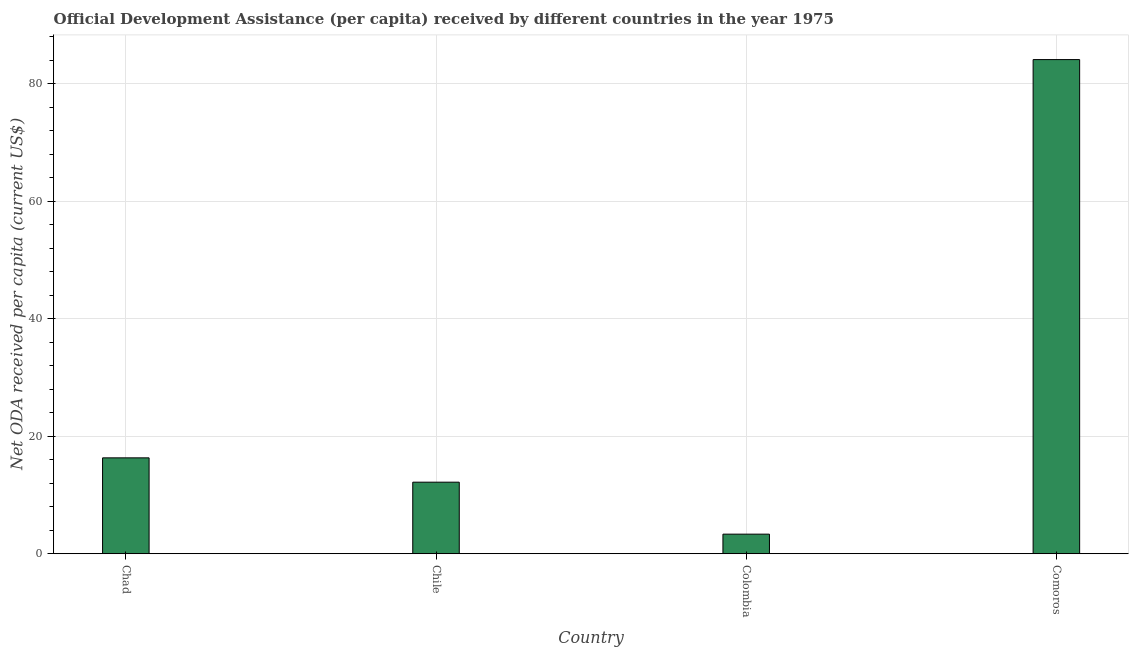Does the graph contain any zero values?
Your answer should be very brief. No. What is the title of the graph?
Make the answer very short. Official Development Assistance (per capita) received by different countries in the year 1975. What is the label or title of the Y-axis?
Your answer should be very brief. Net ODA received per capita (current US$). What is the net oda received per capita in Chad?
Make the answer very short. 16.32. Across all countries, what is the maximum net oda received per capita?
Give a very brief answer. 84.12. Across all countries, what is the minimum net oda received per capita?
Keep it short and to the point. 3.33. In which country was the net oda received per capita maximum?
Your response must be concise. Comoros. What is the sum of the net oda received per capita?
Keep it short and to the point. 115.95. What is the difference between the net oda received per capita in Chad and Colombia?
Give a very brief answer. 12.99. What is the average net oda received per capita per country?
Ensure brevity in your answer.  28.99. What is the median net oda received per capita?
Ensure brevity in your answer.  14.25. In how many countries, is the net oda received per capita greater than 40 US$?
Keep it short and to the point. 1. What is the ratio of the net oda received per capita in Chile to that in Comoros?
Give a very brief answer. 0.14. Is the net oda received per capita in Chad less than that in Chile?
Make the answer very short. No. What is the difference between the highest and the second highest net oda received per capita?
Ensure brevity in your answer.  67.8. What is the difference between the highest and the lowest net oda received per capita?
Your response must be concise. 80.78. How many bars are there?
Your answer should be very brief. 4. Are all the bars in the graph horizontal?
Provide a succinct answer. No. How many countries are there in the graph?
Ensure brevity in your answer.  4. What is the difference between two consecutive major ticks on the Y-axis?
Your answer should be compact. 20. What is the Net ODA received per capita (current US$) in Chad?
Offer a very short reply. 16.32. What is the Net ODA received per capita (current US$) in Chile?
Your response must be concise. 12.18. What is the Net ODA received per capita (current US$) in Colombia?
Offer a very short reply. 3.33. What is the Net ODA received per capita (current US$) in Comoros?
Offer a terse response. 84.12. What is the difference between the Net ODA received per capita (current US$) in Chad and Chile?
Your answer should be very brief. 4.14. What is the difference between the Net ODA received per capita (current US$) in Chad and Colombia?
Your answer should be very brief. 12.99. What is the difference between the Net ODA received per capita (current US$) in Chad and Comoros?
Give a very brief answer. -67.8. What is the difference between the Net ODA received per capita (current US$) in Chile and Colombia?
Provide a short and direct response. 8.85. What is the difference between the Net ODA received per capita (current US$) in Chile and Comoros?
Make the answer very short. -71.94. What is the difference between the Net ODA received per capita (current US$) in Colombia and Comoros?
Your answer should be very brief. -80.78. What is the ratio of the Net ODA received per capita (current US$) in Chad to that in Chile?
Offer a very short reply. 1.34. What is the ratio of the Net ODA received per capita (current US$) in Chad to that in Colombia?
Make the answer very short. 4.9. What is the ratio of the Net ODA received per capita (current US$) in Chad to that in Comoros?
Offer a very short reply. 0.19. What is the ratio of the Net ODA received per capita (current US$) in Chile to that in Colombia?
Offer a very short reply. 3.65. What is the ratio of the Net ODA received per capita (current US$) in Chile to that in Comoros?
Your response must be concise. 0.14. What is the ratio of the Net ODA received per capita (current US$) in Colombia to that in Comoros?
Offer a terse response. 0.04. 